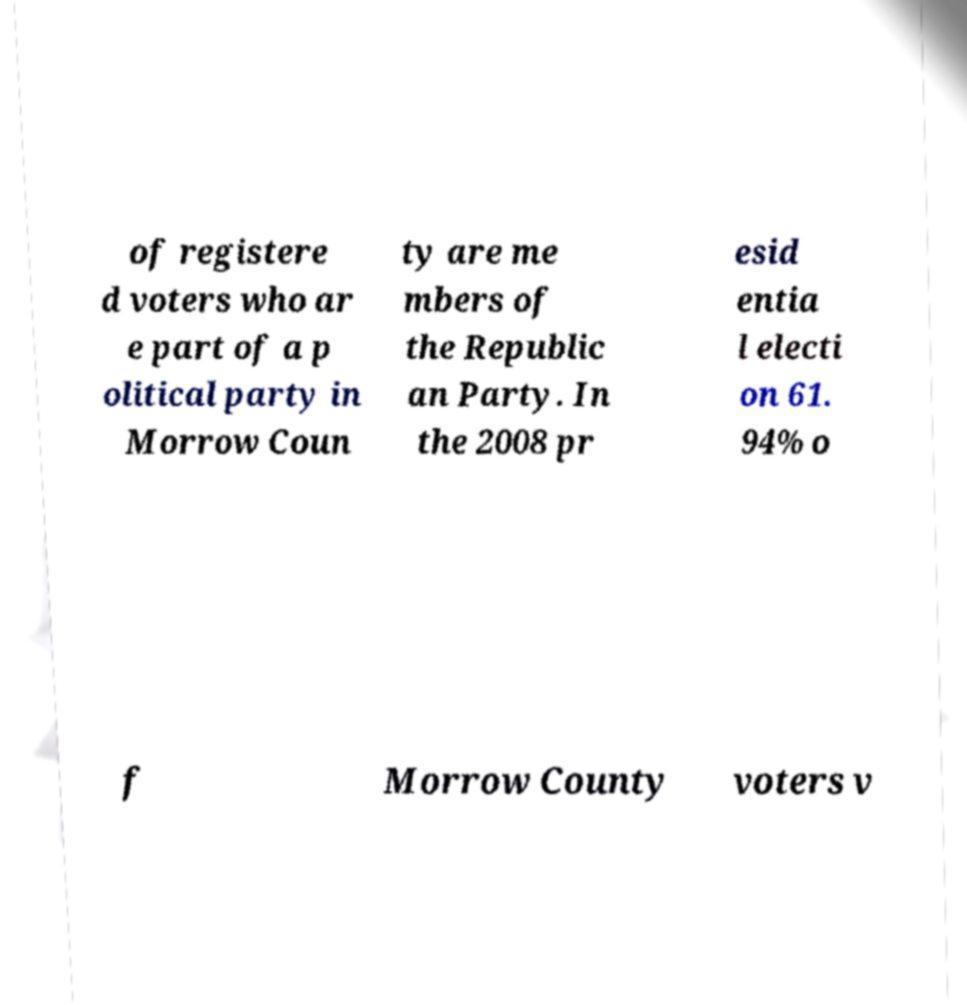Could you assist in decoding the text presented in this image and type it out clearly? of registere d voters who ar e part of a p olitical party in Morrow Coun ty are me mbers of the Republic an Party. In the 2008 pr esid entia l electi on 61. 94% o f Morrow County voters v 